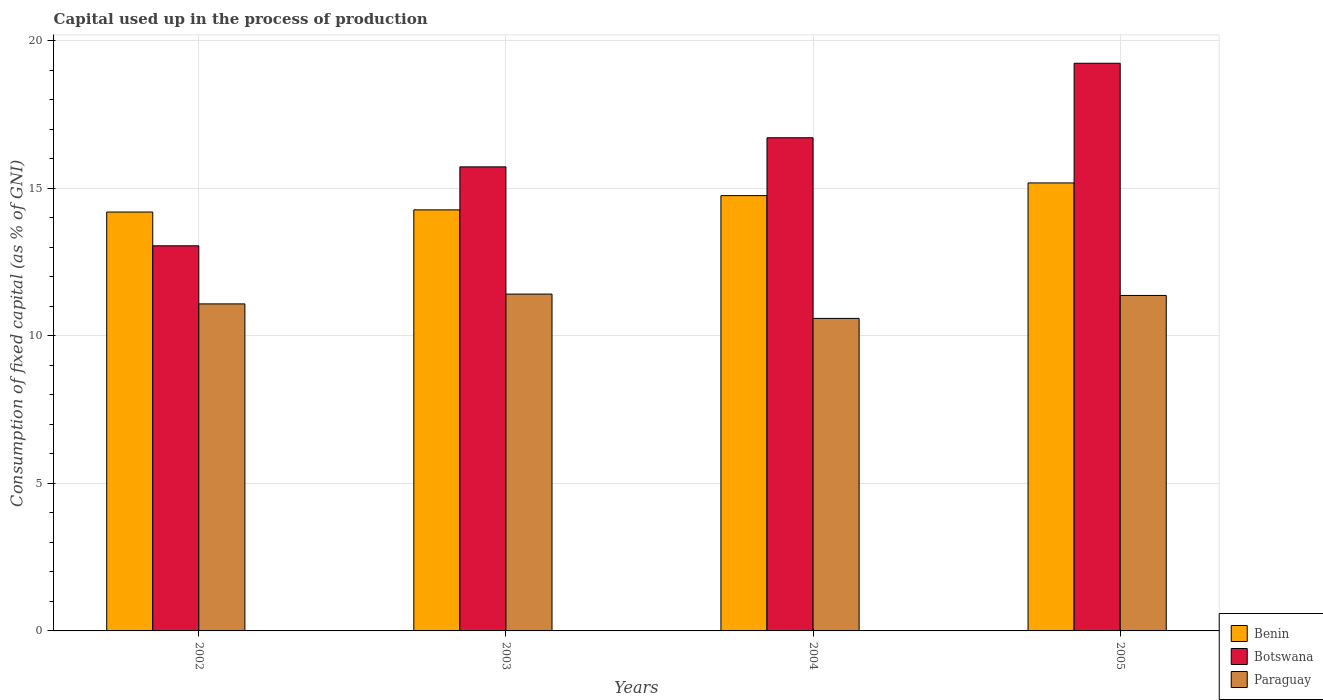Are the number of bars per tick equal to the number of legend labels?
Give a very brief answer. Yes. What is the capital used up in the process of production in Botswana in 2002?
Offer a terse response. 13.05. Across all years, what is the maximum capital used up in the process of production in Benin?
Offer a terse response. 15.18. Across all years, what is the minimum capital used up in the process of production in Paraguay?
Offer a very short reply. 10.59. What is the total capital used up in the process of production in Benin in the graph?
Provide a short and direct response. 58.39. What is the difference between the capital used up in the process of production in Botswana in 2002 and that in 2003?
Your answer should be compact. -2.68. What is the difference between the capital used up in the process of production in Paraguay in 2002 and the capital used up in the process of production in Botswana in 2004?
Keep it short and to the point. -5.63. What is the average capital used up in the process of production in Paraguay per year?
Keep it short and to the point. 11.11. In the year 2002, what is the difference between the capital used up in the process of production in Botswana and capital used up in the process of production in Benin?
Your answer should be very brief. -1.14. What is the ratio of the capital used up in the process of production in Benin in 2002 to that in 2005?
Ensure brevity in your answer.  0.94. Is the capital used up in the process of production in Botswana in 2003 less than that in 2005?
Offer a very short reply. Yes. Is the difference between the capital used up in the process of production in Botswana in 2002 and 2005 greater than the difference between the capital used up in the process of production in Benin in 2002 and 2005?
Your answer should be compact. No. What is the difference between the highest and the second highest capital used up in the process of production in Botswana?
Keep it short and to the point. 2.52. What is the difference between the highest and the lowest capital used up in the process of production in Paraguay?
Offer a very short reply. 0.82. What does the 2nd bar from the left in 2005 represents?
Provide a short and direct response. Botswana. What does the 2nd bar from the right in 2003 represents?
Your response must be concise. Botswana. How many years are there in the graph?
Give a very brief answer. 4. What is the difference between two consecutive major ticks on the Y-axis?
Your response must be concise. 5. What is the title of the graph?
Ensure brevity in your answer.  Capital used up in the process of production. What is the label or title of the X-axis?
Provide a short and direct response. Years. What is the label or title of the Y-axis?
Your answer should be compact. Consumption of fixed capital (as % of GNI). What is the Consumption of fixed capital (as % of GNI) in Benin in 2002?
Your answer should be compact. 14.19. What is the Consumption of fixed capital (as % of GNI) of Botswana in 2002?
Provide a short and direct response. 13.05. What is the Consumption of fixed capital (as % of GNI) in Paraguay in 2002?
Ensure brevity in your answer.  11.08. What is the Consumption of fixed capital (as % of GNI) of Benin in 2003?
Provide a succinct answer. 14.27. What is the Consumption of fixed capital (as % of GNI) in Botswana in 2003?
Your response must be concise. 15.72. What is the Consumption of fixed capital (as % of GNI) in Paraguay in 2003?
Provide a succinct answer. 11.41. What is the Consumption of fixed capital (as % of GNI) in Benin in 2004?
Give a very brief answer. 14.75. What is the Consumption of fixed capital (as % of GNI) in Botswana in 2004?
Offer a terse response. 16.71. What is the Consumption of fixed capital (as % of GNI) of Paraguay in 2004?
Provide a succinct answer. 10.59. What is the Consumption of fixed capital (as % of GNI) in Benin in 2005?
Offer a terse response. 15.18. What is the Consumption of fixed capital (as % of GNI) of Botswana in 2005?
Keep it short and to the point. 19.24. What is the Consumption of fixed capital (as % of GNI) of Paraguay in 2005?
Provide a succinct answer. 11.37. Across all years, what is the maximum Consumption of fixed capital (as % of GNI) of Benin?
Your response must be concise. 15.18. Across all years, what is the maximum Consumption of fixed capital (as % of GNI) of Botswana?
Offer a very short reply. 19.24. Across all years, what is the maximum Consumption of fixed capital (as % of GNI) in Paraguay?
Your answer should be very brief. 11.41. Across all years, what is the minimum Consumption of fixed capital (as % of GNI) in Benin?
Offer a very short reply. 14.19. Across all years, what is the minimum Consumption of fixed capital (as % of GNI) in Botswana?
Your answer should be compact. 13.05. Across all years, what is the minimum Consumption of fixed capital (as % of GNI) in Paraguay?
Make the answer very short. 10.59. What is the total Consumption of fixed capital (as % of GNI) in Benin in the graph?
Ensure brevity in your answer.  58.39. What is the total Consumption of fixed capital (as % of GNI) in Botswana in the graph?
Your response must be concise. 64.72. What is the total Consumption of fixed capital (as % of GNI) of Paraguay in the graph?
Your answer should be compact. 44.45. What is the difference between the Consumption of fixed capital (as % of GNI) of Benin in 2002 and that in 2003?
Ensure brevity in your answer.  -0.07. What is the difference between the Consumption of fixed capital (as % of GNI) in Botswana in 2002 and that in 2003?
Provide a succinct answer. -2.67. What is the difference between the Consumption of fixed capital (as % of GNI) of Paraguay in 2002 and that in 2003?
Keep it short and to the point. -0.33. What is the difference between the Consumption of fixed capital (as % of GNI) in Benin in 2002 and that in 2004?
Provide a succinct answer. -0.56. What is the difference between the Consumption of fixed capital (as % of GNI) in Botswana in 2002 and that in 2004?
Your answer should be very brief. -3.66. What is the difference between the Consumption of fixed capital (as % of GNI) of Paraguay in 2002 and that in 2004?
Provide a succinct answer. 0.49. What is the difference between the Consumption of fixed capital (as % of GNI) of Benin in 2002 and that in 2005?
Your answer should be very brief. -0.99. What is the difference between the Consumption of fixed capital (as % of GNI) in Botswana in 2002 and that in 2005?
Make the answer very short. -6.19. What is the difference between the Consumption of fixed capital (as % of GNI) in Paraguay in 2002 and that in 2005?
Provide a short and direct response. -0.29. What is the difference between the Consumption of fixed capital (as % of GNI) of Benin in 2003 and that in 2004?
Your answer should be very brief. -0.48. What is the difference between the Consumption of fixed capital (as % of GNI) in Botswana in 2003 and that in 2004?
Your response must be concise. -0.99. What is the difference between the Consumption of fixed capital (as % of GNI) of Paraguay in 2003 and that in 2004?
Offer a terse response. 0.82. What is the difference between the Consumption of fixed capital (as % of GNI) of Benin in 2003 and that in 2005?
Ensure brevity in your answer.  -0.91. What is the difference between the Consumption of fixed capital (as % of GNI) of Botswana in 2003 and that in 2005?
Provide a short and direct response. -3.51. What is the difference between the Consumption of fixed capital (as % of GNI) in Paraguay in 2003 and that in 2005?
Offer a very short reply. 0.05. What is the difference between the Consumption of fixed capital (as % of GNI) of Benin in 2004 and that in 2005?
Your answer should be very brief. -0.43. What is the difference between the Consumption of fixed capital (as % of GNI) in Botswana in 2004 and that in 2005?
Your answer should be compact. -2.52. What is the difference between the Consumption of fixed capital (as % of GNI) of Paraguay in 2004 and that in 2005?
Make the answer very short. -0.78. What is the difference between the Consumption of fixed capital (as % of GNI) in Benin in 2002 and the Consumption of fixed capital (as % of GNI) in Botswana in 2003?
Offer a terse response. -1.53. What is the difference between the Consumption of fixed capital (as % of GNI) in Benin in 2002 and the Consumption of fixed capital (as % of GNI) in Paraguay in 2003?
Your answer should be very brief. 2.78. What is the difference between the Consumption of fixed capital (as % of GNI) of Botswana in 2002 and the Consumption of fixed capital (as % of GNI) of Paraguay in 2003?
Ensure brevity in your answer.  1.64. What is the difference between the Consumption of fixed capital (as % of GNI) in Benin in 2002 and the Consumption of fixed capital (as % of GNI) in Botswana in 2004?
Offer a very short reply. -2.52. What is the difference between the Consumption of fixed capital (as % of GNI) in Benin in 2002 and the Consumption of fixed capital (as % of GNI) in Paraguay in 2004?
Provide a short and direct response. 3.6. What is the difference between the Consumption of fixed capital (as % of GNI) in Botswana in 2002 and the Consumption of fixed capital (as % of GNI) in Paraguay in 2004?
Offer a terse response. 2.46. What is the difference between the Consumption of fixed capital (as % of GNI) of Benin in 2002 and the Consumption of fixed capital (as % of GNI) of Botswana in 2005?
Provide a succinct answer. -5.04. What is the difference between the Consumption of fixed capital (as % of GNI) of Benin in 2002 and the Consumption of fixed capital (as % of GNI) of Paraguay in 2005?
Provide a short and direct response. 2.83. What is the difference between the Consumption of fixed capital (as % of GNI) in Botswana in 2002 and the Consumption of fixed capital (as % of GNI) in Paraguay in 2005?
Your response must be concise. 1.68. What is the difference between the Consumption of fixed capital (as % of GNI) of Benin in 2003 and the Consumption of fixed capital (as % of GNI) of Botswana in 2004?
Give a very brief answer. -2.44. What is the difference between the Consumption of fixed capital (as % of GNI) of Benin in 2003 and the Consumption of fixed capital (as % of GNI) of Paraguay in 2004?
Offer a very short reply. 3.68. What is the difference between the Consumption of fixed capital (as % of GNI) in Botswana in 2003 and the Consumption of fixed capital (as % of GNI) in Paraguay in 2004?
Your response must be concise. 5.13. What is the difference between the Consumption of fixed capital (as % of GNI) of Benin in 2003 and the Consumption of fixed capital (as % of GNI) of Botswana in 2005?
Provide a succinct answer. -4.97. What is the difference between the Consumption of fixed capital (as % of GNI) in Benin in 2003 and the Consumption of fixed capital (as % of GNI) in Paraguay in 2005?
Make the answer very short. 2.9. What is the difference between the Consumption of fixed capital (as % of GNI) in Botswana in 2003 and the Consumption of fixed capital (as % of GNI) in Paraguay in 2005?
Ensure brevity in your answer.  4.36. What is the difference between the Consumption of fixed capital (as % of GNI) of Benin in 2004 and the Consumption of fixed capital (as % of GNI) of Botswana in 2005?
Offer a very short reply. -4.49. What is the difference between the Consumption of fixed capital (as % of GNI) of Benin in 2004 and the Consumption of fixed capital (as % of GNI) of Paraguay in 2005?
Your answer should be very brief. 3.38. What is the difference between the Consumption of fixed capital (as % of GNI) in Botswana in 2004 and the Consumption of fixed capital (as % of GNI) in Paraguay in 2005?
Make the answer very short. 5.34. What is the average Consumption of fixed capital (as % of GNI) in Benin per year?
Your answer should be compact. 14.6. What is the average Consumption of fixed capital (as % of GNI) in Botswana per year?
Make the answer very short. 16.18. What is the average Consumption of fixed capital (as % of GNI) in Paraguay per year?
Make the answer very short. 11.11. In the year 2002, what is the difference between the Consumption of fixed capital (as % of GNI) of Benin and Consumption of fixed capital (as % of GNI) of Botswana?
Provide a succinct answer. 1.15. In the year 2002, what is the difference between the Consumption of fixed capital (as % of GNI) of Benin and Consumption of fixed capital (as % of GNI) of Paraguay?
Your answer should be very brief. 3.11. In the year 2002, what is the difference between the Consumption of fixed capital (as % of GNI) in Botswana and Consumption of fixed capital (as % of GNI) in Paraguay?
Your answer should be very brief. 1.97. In the year 2003, what is the difference between the Consumption of fixed capital (as % of GNI) of Benin and Consumption of fixed capital (as % of GNI) of Botswana?
Your response must be concise. -1.46. In the year 2003, what is the difference between the Consumption of fixed capital (as % of GNI) of Benin and Consumption of fixed capital (as % of GNI) of Paraguay?
Offer a very short reply. 2.85. In the year 2003, what is the difference between the Consumption of fixed capital (as % of GNI) of Botswana and Consumption of fixed capital (as % of GNI) of Paraguay?
Your answer should be very brief. 4.31. In the year 2004, what is the difference between the Consumption of fixed capital (as % of GNI) in Benin and Consumption of fixed capital (as % of GNI) in Botswana?
Ensure brevity in your answer.  -1.96. In the year 2004, what is the difference between the Consumption of fixed capital (as % of GNI) of Benin and Consumption of fixed capital (as % of GNI) of Paraguay?
Your answer should be very brief. 4.16. In the year 2004, what is the difference between the Consumption of fixed capital (as % of GNI) in Botswana and Consumption of fixed capital (as % of GNI) in Paraguay?
Give a very brief answer. 6.12. In the year 2005, what is the difference between the Consumption of fixed capital (as % of GNI) of Benin and Consumption of fixed capital (as % of GNI) of Botswana?
Give a very brief answer. -4.06. In the year 2005, what is the difference between the Consumption of fixed capital (as % of GNI) in Benin and Consumption of fixed capital (as % of GNI) in Paraguay?
Your answer should be compact. 3.81. In the year 2005, what is the difference between the Consumption of fixed capital (as % of GNI) of Botswana and Consumption of fixed capital (as % of GNI) of Paraguay?
Give a very brief answer. 7.87. What is the ratio of the Consumption of fixed capital (as % of GNI) in Benin in 2002 to that in 2003?
Your answer should be compact. 0.99. What is the ratio of the Consumption of fixed capital (as % of GNI) in Botswana in 2002 to that in 2003?
Ensure brevity in your answer.  0.83. What is the ratio of the Consumption of fixed capital (as % of GNI) in Paraguay in 2002 to that in 2003?
Provide a succinct answer. 0.97. What is the ratio of the Consumption of fixed capital (as % of GNI) of Benin in 2002 to that in 2004?
Give a very brief answer. 0.96. What is the ratio of the Consumption of fixed capital (as % of GNI) in Botswana in 2002 to that in 2004?
Your answer should be very brief. 0.78. What is the ratio of the Consumption of fixed capital (as % of GNI) of Paraguay in 2002 to that in 2004?
Your response must be concise. 1.05. What is the ratio of the Consumption of fixed capital (as % of GNI) of Benin in 2002 to that in 2005?
Offer a very short reply. 0.94. What is the ratio of the Consumption of fixed capital (as % of GNI) of Botswana in 2002 to that in 2005?
Your response must be concise. 0.68. What is the ratio of the Consumption of fixed capital (as % of GNI) of Paraguay in 2002 to that in 2005?
Offer a terse response. 0.97. What is the ratio of the Consumption of fixed capital (as % of GNI) of Benin in 2003 to that in 2004?
Offer a terse response. 0.97. What is the ratio of the Consumption of fixed capital (as % of GNI) in Botswana in 2003 to that in 2004?
Give a very brief answer. 0.94. What is the ratio of the Consumption of fixed capital (as % of GNI) in Paraguay in 2003 to that in 2004?
Give a very brief answer. 1.08. What is the ratio of the Consumption of fixed capital (as % of GNI) in Benin in 2003 to that in 2005?
Your answer should be compact. 0.94. What is the ratio of the Consumption of fixed capital (as % of GNI) in Botswana in 2003 to that in 2005?
Provide a short and direct response. 0.82. What is the ratio of the Consumption of fixed capital (as % of GNI) in Paraguay in 2003 to that in 2005?
Make the answer very short. 1. What is the ratio of the Consumption of fixed capital (as % of GNI) in Benin in 2004 to that in 2005?
Provide a short and direct response. 0.97. What is the ratio of the Consumption of fixed capital (as % of GNI) of Botswana in 2004 to that in 2005?
Offer a terse response. 0.87. What is the ratio of the Consumption of fixed capital (as % of GNI) in Paraguay in 2004 to that in 2005?
Your answer should be compact. 0.93. What is the difference between the highest and the second highest Consumption of fixed capital (as % of GNI) of Benin?
Offer a very short reply. 0.43. What is the difference between the highest and the second highest Consumption of fixed capital (as % of GNI) in Botswana?
Offer a very short reply. 2.52. What is the difference between the highest and the second highest Consumption of fixed capital (as % of GNI) of Paraguay?
Keep it short and to the point. 0.05. What is the difference between the highest and the lowest Consumption of fixed capital (as % of GNI) of Benin?
Keep it short and to the point. 0.99. What is the difference between the highest and the lowest Consumption of fixed capital (as % of GNI) of Botswana?
Your response must be concise. 6.19. What is the difference between the highest and the lowest Consumption of fixed capital (as % of GNI) of Paraguay?
Keep it short and to the point. 0.82. 